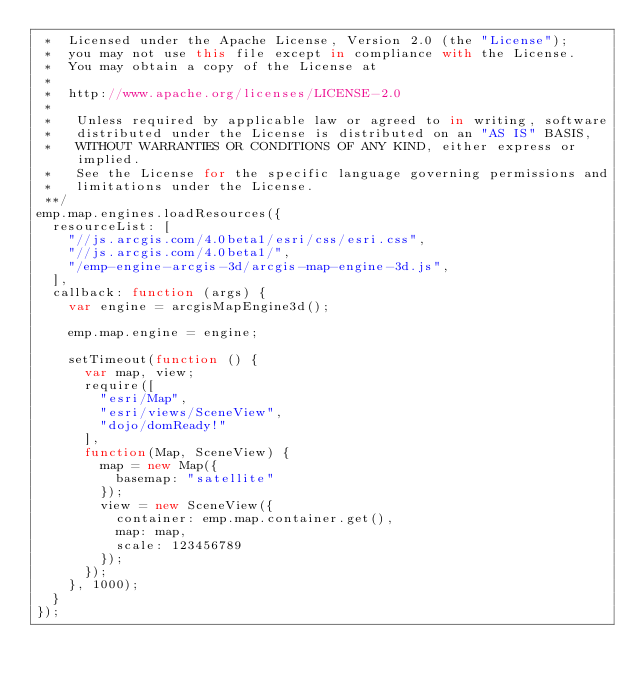<code> <loc_0><loc_0><loc_500><loc_500><_JavaScript_> *  Licensed under the Apache License, Version 2.0 (the "License");
 *  you may not use this file except in compliance with the License.
 *  You may obtain a copy of the License at
 * 
 *  http://www.apache.org/licenses/LICENSE-2.0
 *  
 *   Unless required by applicable law or agreed to in writing, software
 *   distributed under the License is distributed on an "AS IS" BASIS,
 *   WITHOUT WARRANTIES OR CONDITIONS OF ANY KIND, either express or implied.
 *   See the License for the specific language governing permissions and
 *   limitations under the License.
 **/
emp.map.engines.loadResources({
  resourceList: [
    "//js.arcgis.com/4.0beta1/esri/css/esri.css",
    "//js.arcgis.com/4.0beta1/",
    "/emp-engine-arcgis-3d/arcgis-map-engine-3d.js",
  ],
  callback: function (args) {
    var engine = arcgisMapEngine3d();

    emp.map.engine = engine;

    setTimeout(function () {
      var map, view;
      require([
        "esri/Map",
        "esri/views/SceneView",
        "dojo/domReady!"
      ],
      function(Map, SceneView) {
        map = new Map({
          basemap: "satellite"
        });
        view = new SceneView({
          container: emp.map.container.get(),
          map: map,
          scale: 123456789
        });
      });
    }, 1000);
  }
});</code> 